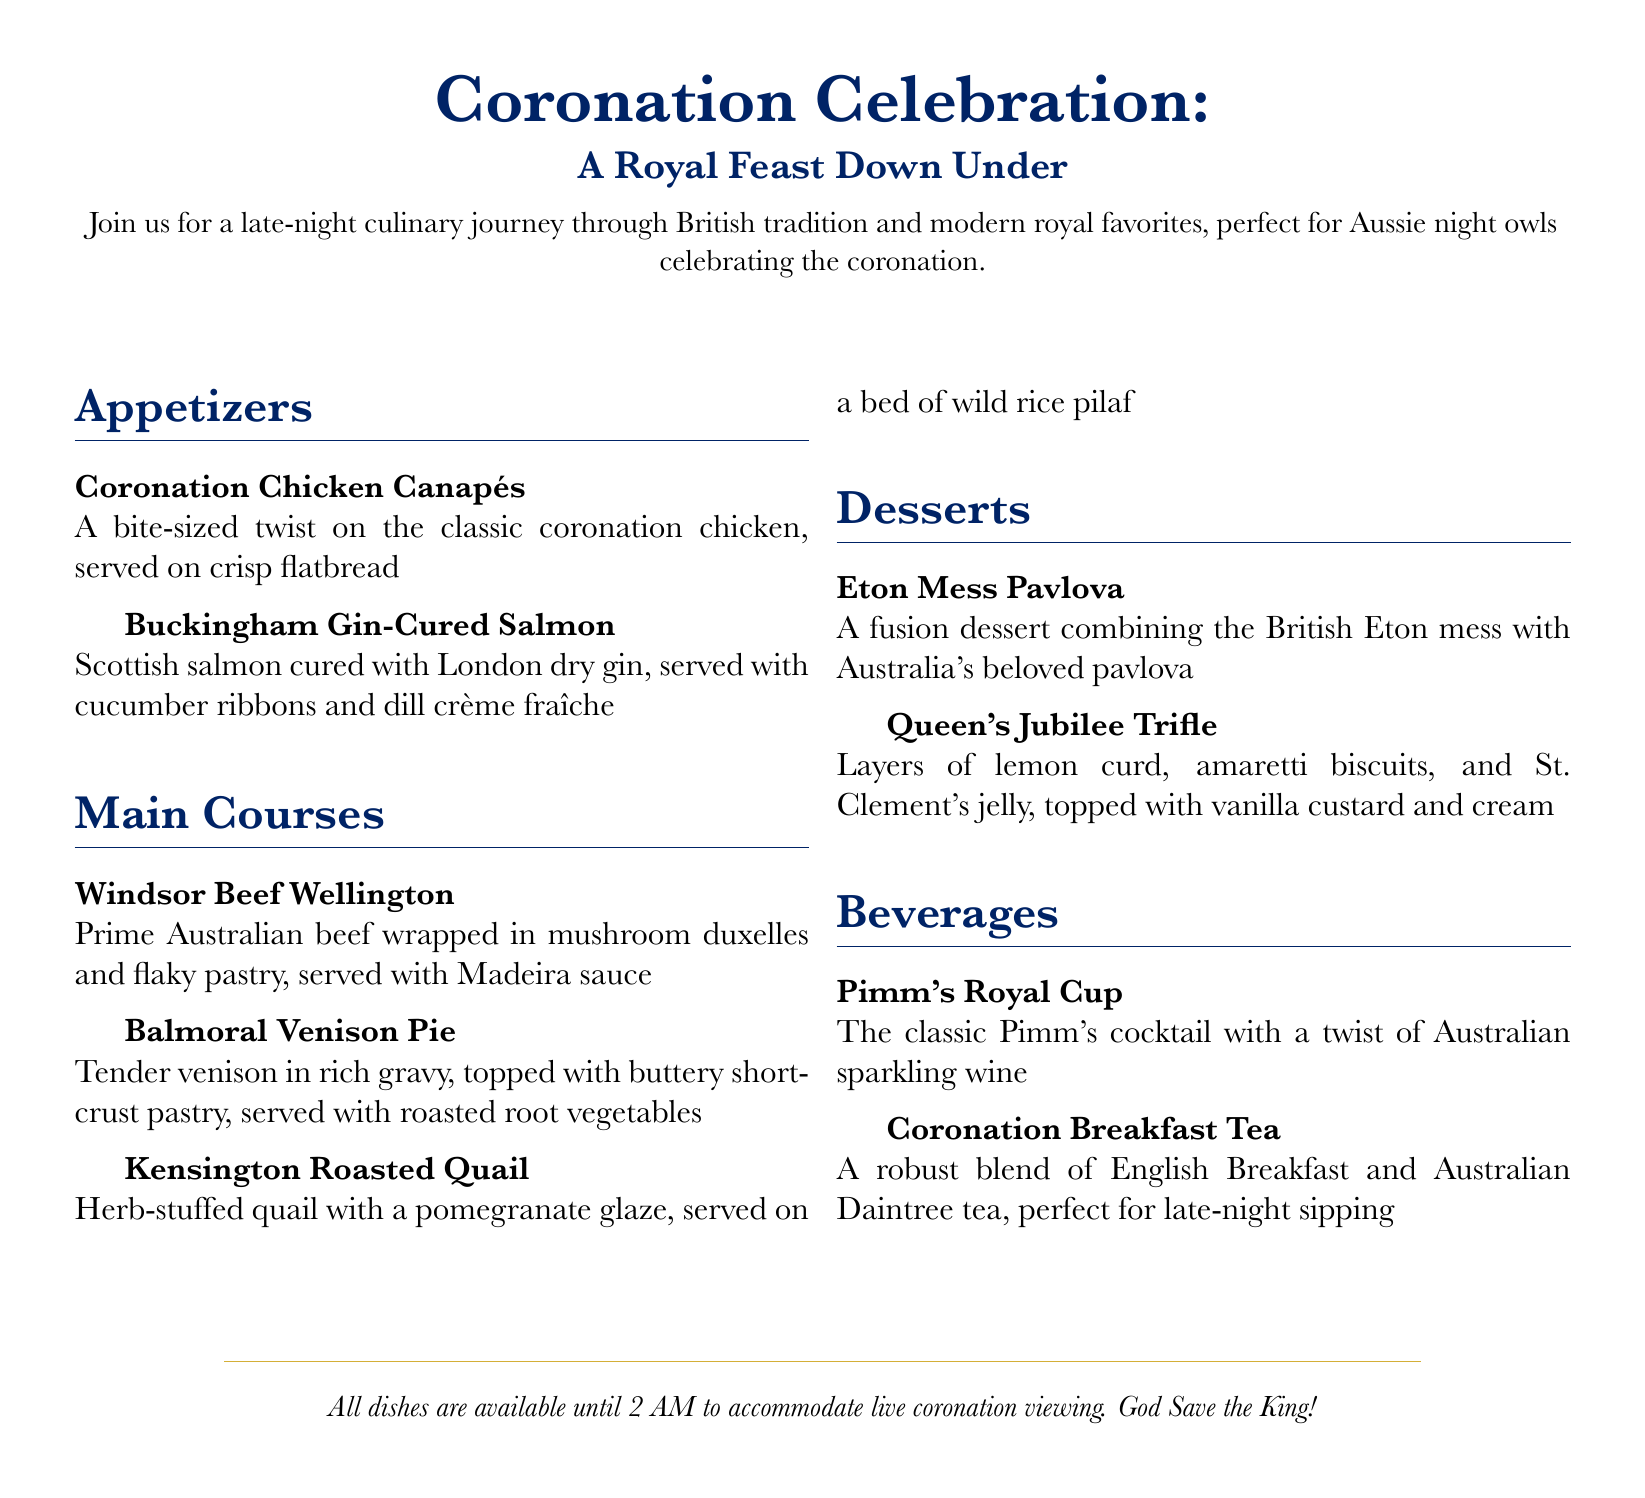What is the title of the menu? The title of the menu is prominently displayed at the top of the document.
Answer: Coronation Celebration What type of dishes are featured in the menu? The menu features a mix of traditional British dishes and modern interpretations, as mentioned in the introduction.
Answer: Traditional and modern What is one of the appetizers listed? The appetizers section lists several items, and one can be cited directly from this section.
Answer: Coronation Chicken Canapés How late is the menu available until? The document explicitly states the service time for all dishes.
Answer: 2 AM What is the name of the dessert that combines Eton mess and pavlova? This dessert is specifically named in the dessert section of the menu.
Answer: Eton Mess Pavlova Which beverage includes Australian sparkling wine? The beverage section contains a specific drink that matches this description.
Answer: Pimm's Royal Cup How many main courses are listed in the menu? Counting the items in the main courses section will yield this information.
Answer: 3 What is the serving style of the Buckingham Gin-Cured Salmon? The description of this dish provides insight into its presentation.
Answer: Served with cucumber ribbons and dill crème fraîche What unique ingredient is used in the Kensington Roasted Quail? The document specifies what the quail is stuffed with in the description.
Answer: Herb-stuffed 